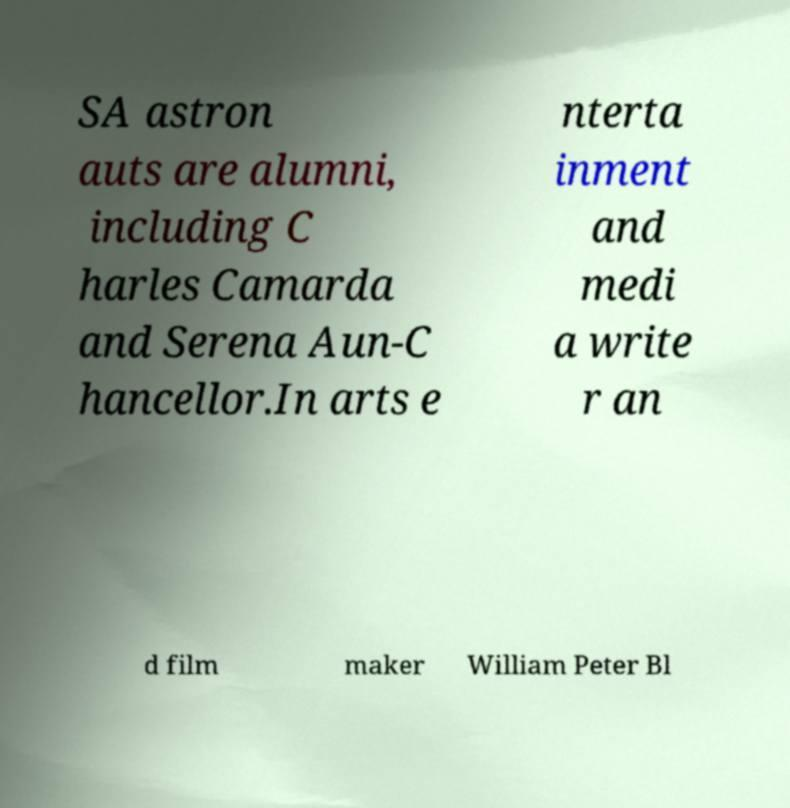Can you read and provide the text displayed in the image?This photo seems to have some interesting text. Can you extract and type it out for me? SA astron auts are alumni, including C harles Camarda and Serena Aun-C hancellor.In arts e nterta inment and medi a write r an d film maker William Peter Bl 